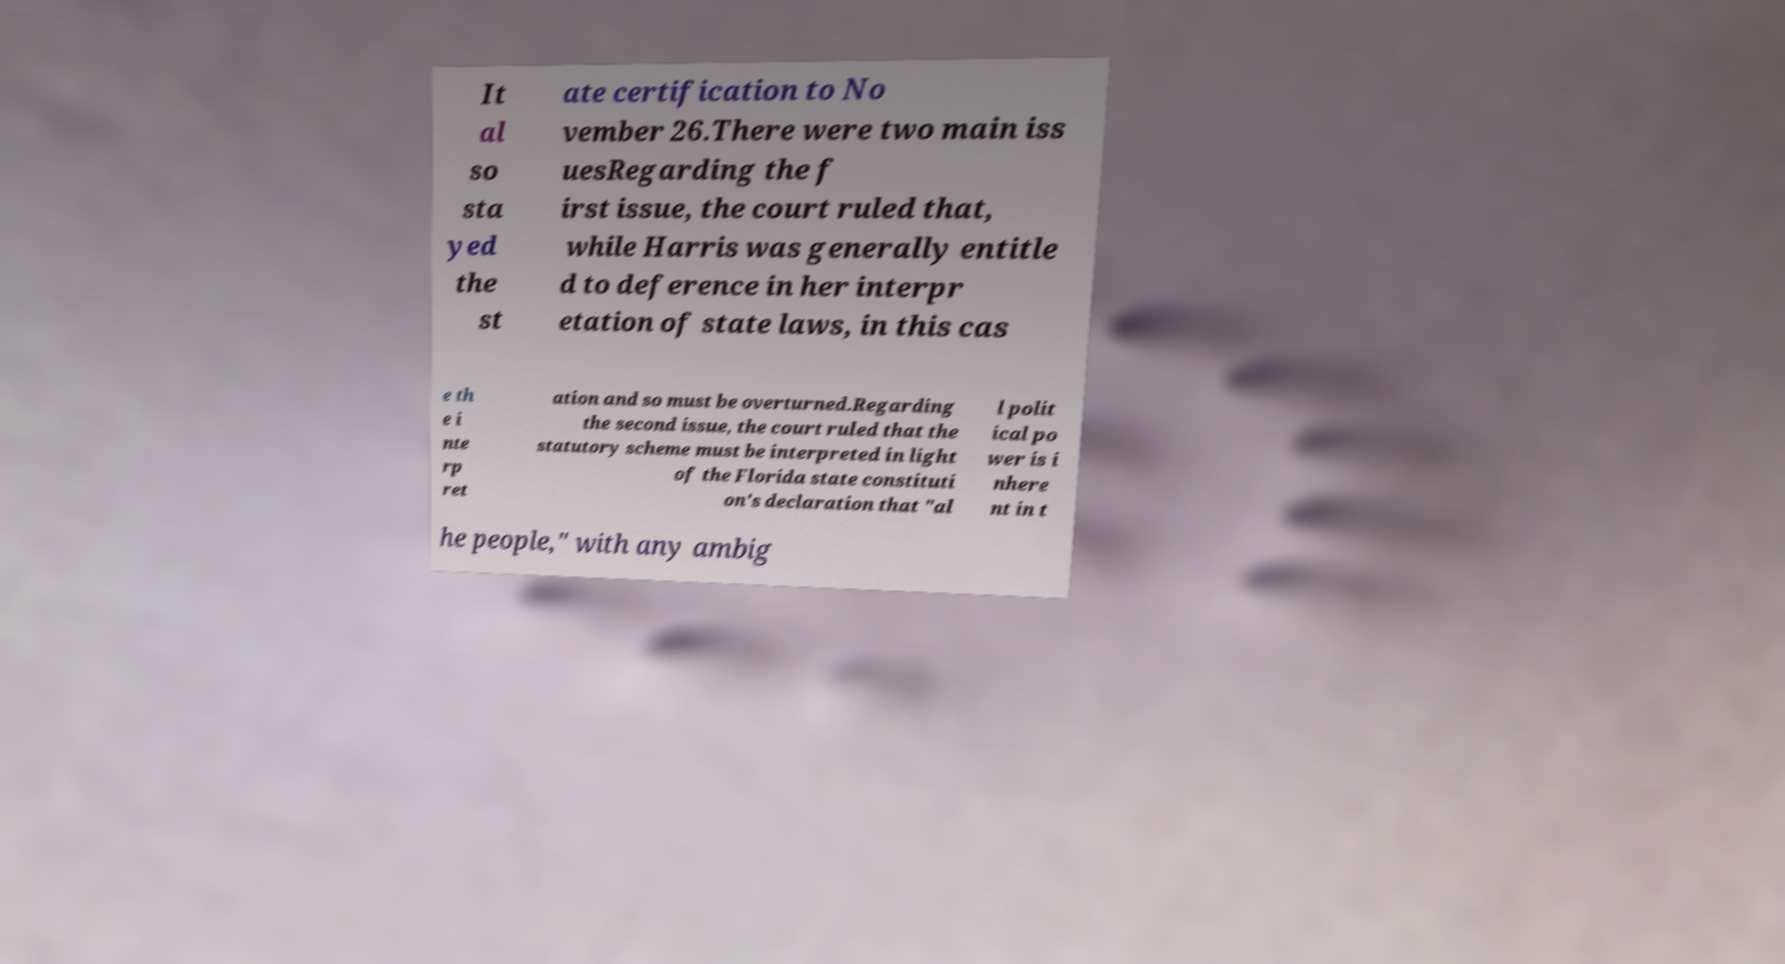Can you accurately transcribe the text from the provided image for me? It al so sta yed the st ate certification to No vember 26.There were two main iss uesRegarding the f irst issue, the court ruled that, while Harris was generally entitle d to deference in her interpr etation of state laws, in this cas e th e i nte rp ret ation and so must be overturned.Regarding the second issue, the court ruled that the statutory scheme must be interpreted in light of the Florida state constituti on's declaration that "al l polit ical po wer is i nhere nt in t he people," with any ambig 